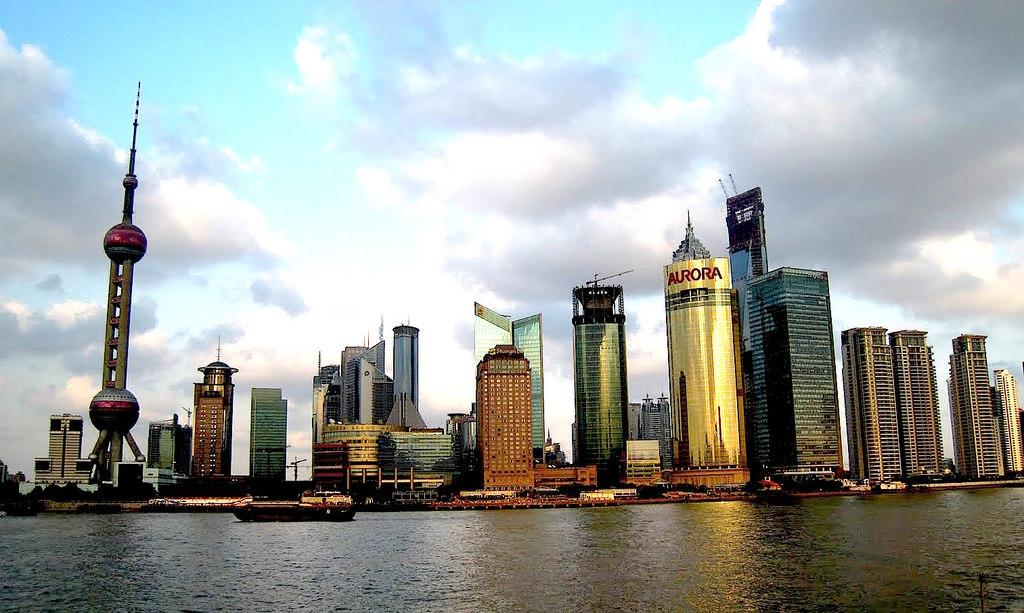What is the main subject of the image? The main subject of the image is water. What is present on the water? There are boats on the water. What can be seen in the background of the image? There are buildings and a cloudy sky in the background of the image. What type of tooth is visible in the image? There is no tooth present in the image. Is there a tray holding dental instruments in the image? There is no tray or dental instruments present in the image. 